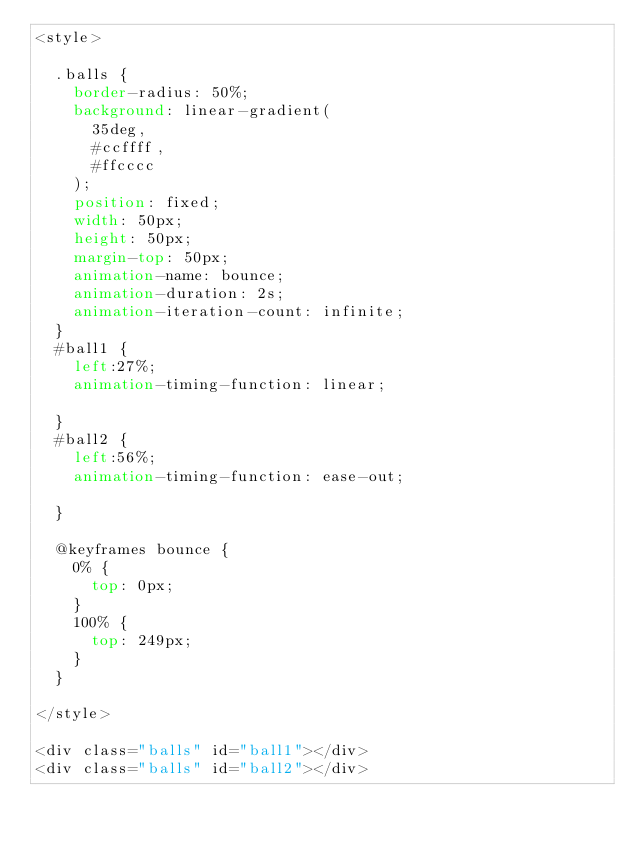Convert code to text. <code><loc_0><loc_0><loc_500><loc_500><_CSS_><style>

  .balls {
    border-radius: 50%;
    background: linear-gradient(
      35deg,
      #ccffff,
      #ffcccc
    );
    position: fixed;
    width: 50px;
    height: 50px;
    margin-top: 50px;
    animation-name: bounce;
    animation-duration: 2s;
    animation-iteration-count: infinite;
  }
  #ball1 {
    left:27%;
    animation-timing-function: linear;

  }
  #ball2 {
    left:56%;
    animation-timing-function: ease-out;

  }

  @keyframes bounce {
    0% {
      top: 0px;
    }
    100% {
      top: 249px;
    }
  }

</style>

<div class="balls" id="ball1"></div>
<div class="balls" id="ball2"></div>
</code> 